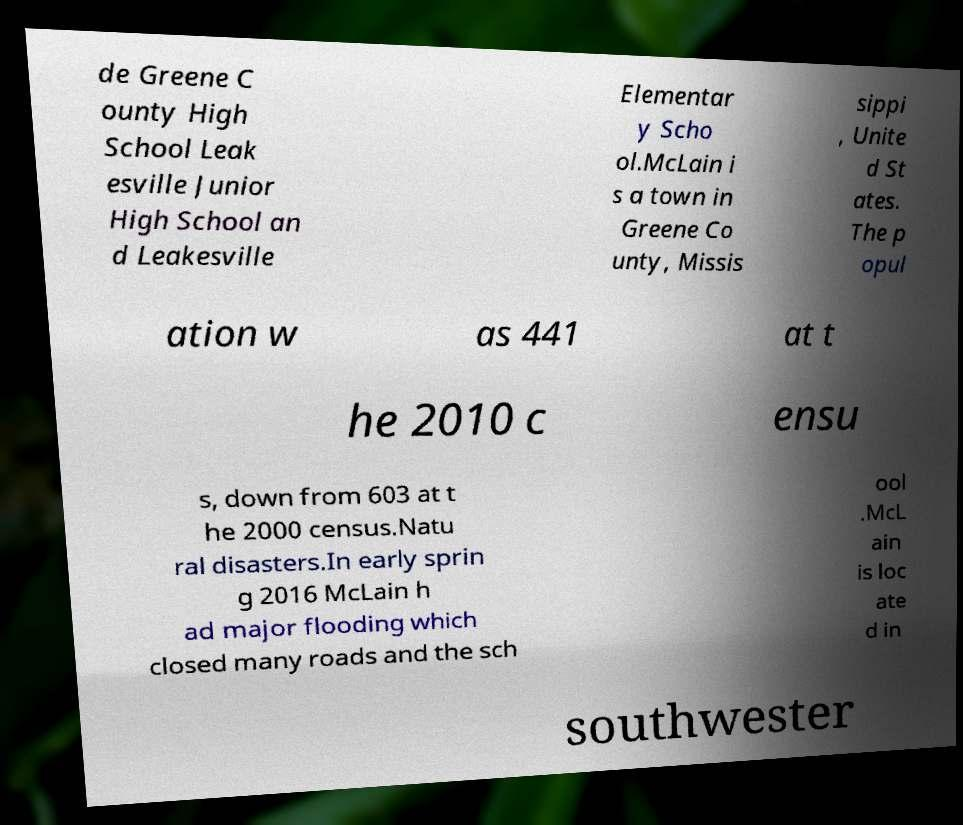Can you accurately transcribe the text from the provided image for me? de Greene C ounty High School Leak esville Junior High School an d Leakesville Elementar y Scho ol.McLain i s a town in Greene Co unty, Missis sippi , Unite d St ates. The p opul ation w as 441 at t he 2010 c ensu s, down from 603 at t he 2000 census.Natu ral disasters.In early sprin g 2016 McLain h ad major flooding which closed many roads and the sch ool .McL ain is loc ate d in southwester 